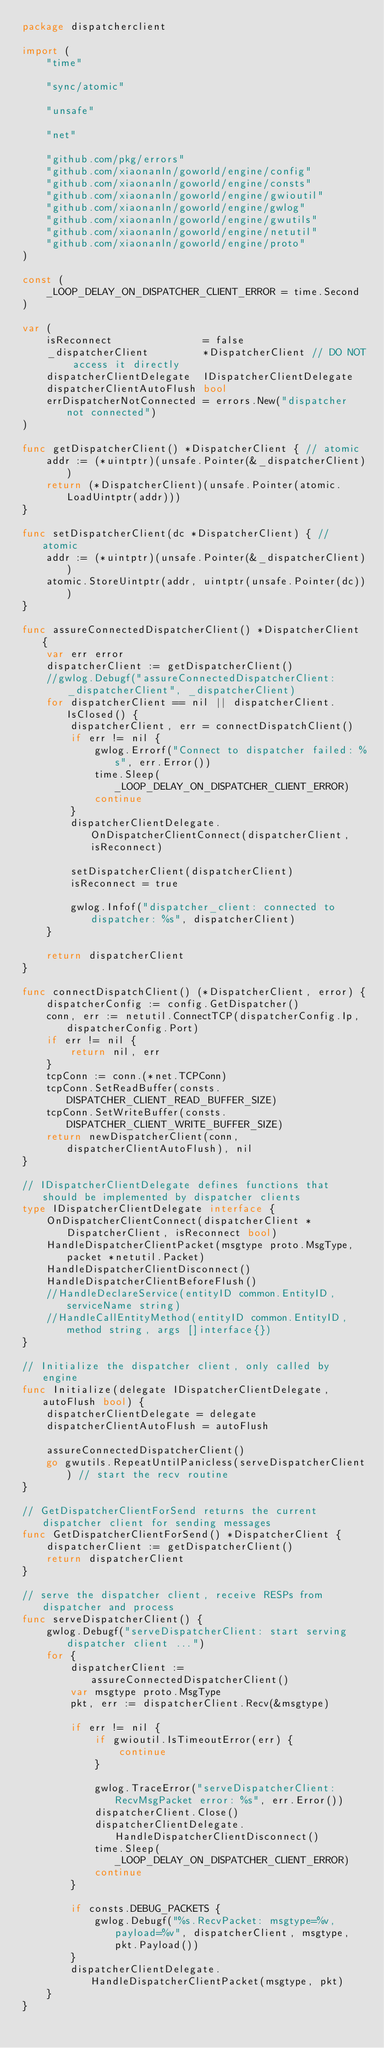<code> <loc_0><loc_0><loc_500><loc_500><_Go_>package dispatcherclient

import (
	"time"

	"sync/atomic"

	"unsafe"

	"net"

	"github.com/pkg/errors"
	"github.com/xiaonanln/goworld/engine/config"
	"github.com/xiaonanln/goworld/engine/consts"
	"github.com/xiaonanln/goworld/engine/gwioutil"
	"github.com/xiaonanln/goworld/engine/gwlog"
	"github.com/xiaonanln/goworld/engine/gwutils"
	"github.com/xiaonanln/goworld/engine/netutil"
	"github.com/xiaonanln/goworld/engine/proto"
)

const (
	_LOOP_DELAY_ON_DISPATCHER_CLIENT_ERROR = time.Second
)

var (
	isReconnect               = false
	_dispatcherClient         *DispatcherClient // DO NOT access it directly
	dispatcherClientDelegate  IDispatcherClientDelegate
	dispatcherClientAutoFlush bool
	errDispatcherNotConnected = errors.New("dispatcher not connected")
)

func getDispatcherClient() *DispatcherClient { // atomic
	addr := (*uintptr)(unsafe.Pointer(&_dispatcherClient))
	return (*DispatcherClient)(unsafe.Pointer(atomic.LoadUintptr(addr)))
}

func setDispatcherClient(dc *DispatcherClient) { // atomic
	addr := (*uintptr)(unsafe.Pointer(&_dispatcherClient))
	atomic.StoreUintptr(addr, uintptr(unsafe.Pointer(dc)))
}

func assureConnectedDispatcherClient() *DispatcherClient {
	var err error
	dispatcherClient := getDispatcherClient()
	//gwlog.Debugf("assureConnectedDispatcherClient: _dispatcherClient", _dispatcherClient)
	for dispatcherClient == nil || dispatcherClient.IsClosed() {
		dispatcherClient, err = connectDispatchClient()
		if err != nil {
			gwlog.Errorf("Connect to dispatcher failed: %s", err.Error())
			time.Sleep(_LOOP_DELAY_ON_DISPATCHER_CLIENT_ERROR)
			continue
		}
		dispatcherClientDelegate.OnDispatcherClientConnect(dispatcherClient, isReconnect)

		setDispatcherClient(dispatcherClient)
		isReconnect = true

		gwlog.Infof("dispatcher_client: connected to dispatcher: %s", dispatcherClient)
	}

	return dispatcherClient
}

func connectDispatchClient() (*DispatcherClient, error) {
	dispatcherConfig := config.GetDispatcher()
	conn, err := netutil.ConnectTCP(dispatcherConfig.Ip, dispatcherConfig.Port)
	if err != nil {
		return nil, err
	}
	tcpConn := conn.(*net.TCPConn)
	tcpConn.SetReadBuffer(consts.DISPATCHER_CLIENT_READ_BUFFER_SIZE)
	tcpConn.SetWriteBuffer(consts.DISPATCHER_CLIENT_WRITE_BUFFER_SIZE)
	return newDispatcherClient(conn, dispatcherClientAutoFlush), nil
}

// IDispatcherClientDelegate defines functions that should be implemented by dispatcher clients
type IDispatcherClientDelegate interface {
	OnDispatcherClientConnect(dispatcherClient *DispatcherClient, isReconnect bool)
	HandleDispatcherClientPacket(msgtype proto.MsgType, packet *netutil.Packet)
	HandleDispatcherClientDisconnect()
	HandleDispatcherClientBeforeFlush()
	//HandleDeclareService(entityID common.EntityID, serviceName string)
	//HandleCallEntityMethod(entityID common.EntityID, method string, args []interface{})
}

// Initialize the dispatcher client, only called by engine
func Initialize(delegate IDispatcherClientDelegate, autoFlush bool) {
	dispatcherClientDelegate = delegate
	dispatcherClientAutoFlush = autoFlush

	assureConnectedDispatcherClient()
	go gwutils.RepeatUntilPanicless(serveDispatcherClient) // start the recv routine
}

// GetDispatcherClientForSend returns the current dispatcher client for sending messages
func GetDispatcherClientForSend() *DispatcherClient {
	dispatcherClient := getDispatcherClient()
	return dispatcherClient
}

// serve the dispatcher client, receive RESPs from dispatcher and process
func serveDispatcherClient() {
	gwlog.Debugf("serveDispatcherClient: start serving dispatcher client ...")
	for {
		dispatcherClient := assureConnectedDispatcherClient()
		var msgtype proto.MsgType
		pkt, err := dispatcherClient.Recv(&msgtype)

		if err != nil {
			if gwioutil.IsTimeoutError(err) {
				continue
			}

			gwlog.TraceError("serveDispatcherClient: RecvMsgPacket error: %s", err.Error())
			dispatcherClient.Close()
			dispatcherClientDelegate.HandleDispatcherClientDisconnect()
			time.Sleep(_LOOP_DELAY_ON_DISPATCHER_CLIENT_ERROR)
			continue
		}

		if consts.DEBUG_PACKETS {
			gwlog.Debugf("%s.RecvPacket: msgtype=%v, payload=%v", dispatcherClient, msgtype, pkt.Payload())
		}
		dispatcherClientDelegate.HandleDispatcherClientPacket(msgtype, pkt)
	}
}
</code> 